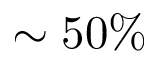<formula> <loc_0><loc_0><loc_500><loc_500>\sim 5 0 \%</formula> 